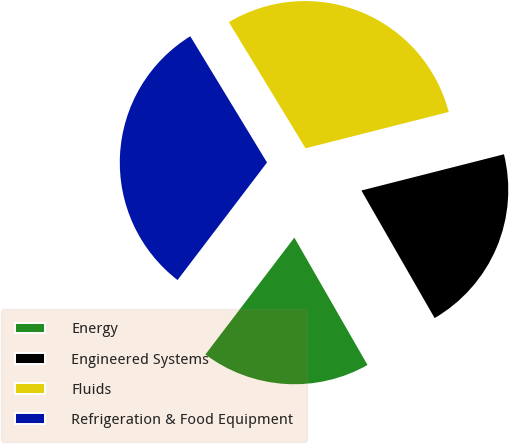Convert chart to OTSL. <chart><loc_0><loc_0><loc_500><loc_500><pie_chart><fcel>Energy<fcel>Engineered Systems<fcel>Fluids<fcel>Refrigeration & Food Equipment<nl><fcel>18.65%<fcel>20.66%<fcel>29.73%<fcel>30.95%<nl></chart> 